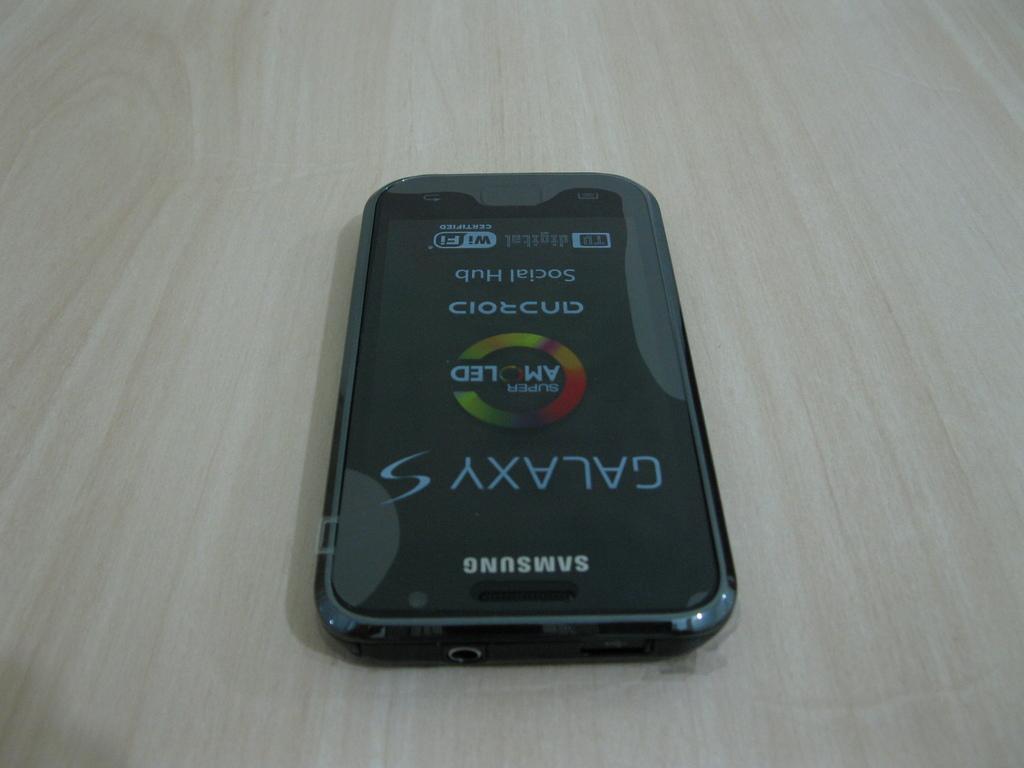What it is barand?
Give a very brief answer. Samsung. What is the type of phone pictured here?
Your answer should be very brief. Samsung. 